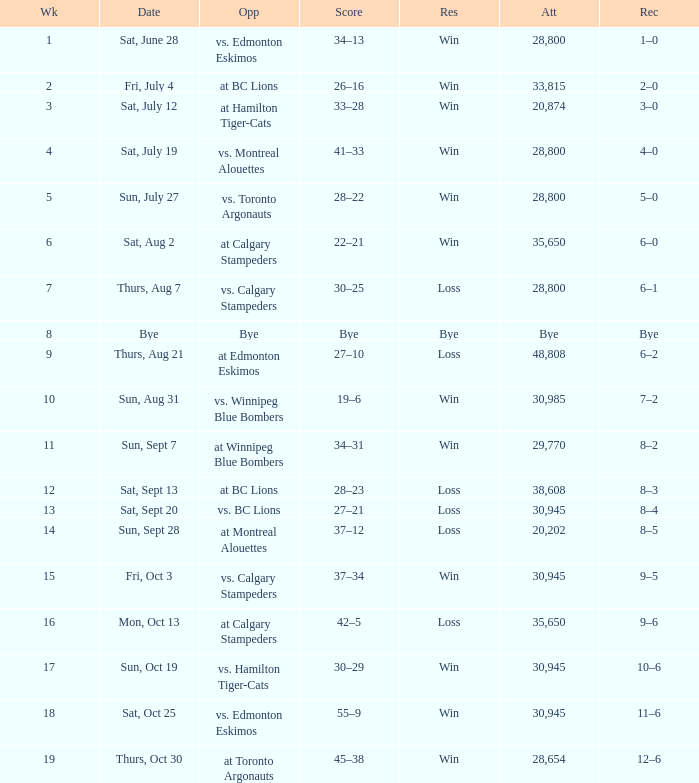What was the record the the match against vs. calgary stampeders before week 15? 6–1. 